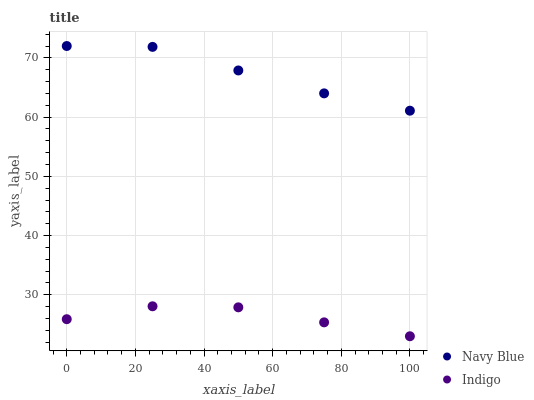Does Indigo have the minimum area under the curve?
Answer yes or no. Yes. Does Navy Blue have the maximum area under the curve?
Answer yes or no. Yes. Does Indigo have the maximum area under the curve?
Answer yes or no. No. Is Navy Blue the smoothest?
Answer yes or no. Yes. Is Indigo the roughest?
Answer yes or no. Yes. Is Indigo the smoothest?
Answer yes or no. No. Does Indigo have the lowest value?
Answer yes or no. Yes. Does Navy Blue have the highest value?
Answer yes or no. Yes. Does Indigo have the highest value?
Answer yes or no. No. Is Indigo less than Navy Blue?
Answer yes or no. Yes. Is Navy Blue greater than Indigo?
Answer yes or no. Yes. Does Indigo intersect Navy Blue?
Answer yes or no. No. 